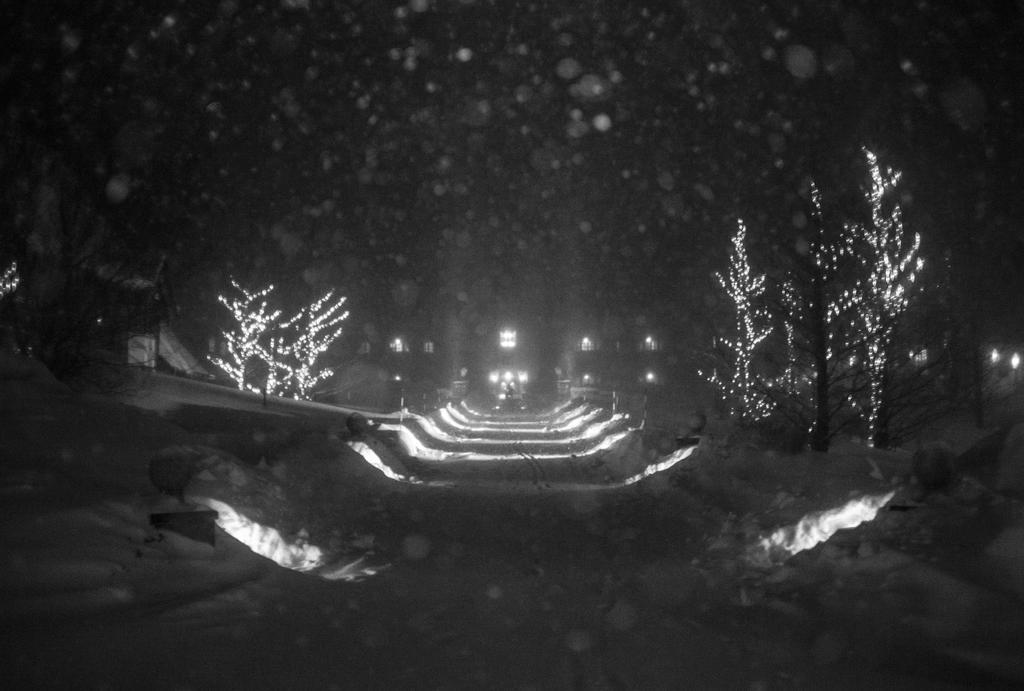What is located in the middle of the image? In the middle of the image, there are lights, trees, plants, buildings, windows, and the sky is visible. Can you describe the elements in the middle of the image in more detail? The lights are likely streetlights, the trees are likely deciduous trees, the plants could be various types of plants, the buildings are likely residential or commercial structures, the windows are likely part of the buildings, and the sky is likely a mix of clouds and blue sky. What type of trouble is the fire causing in the image? There is no fire present in the image, so it is not possible to determine what type of trouble it might be causing. 